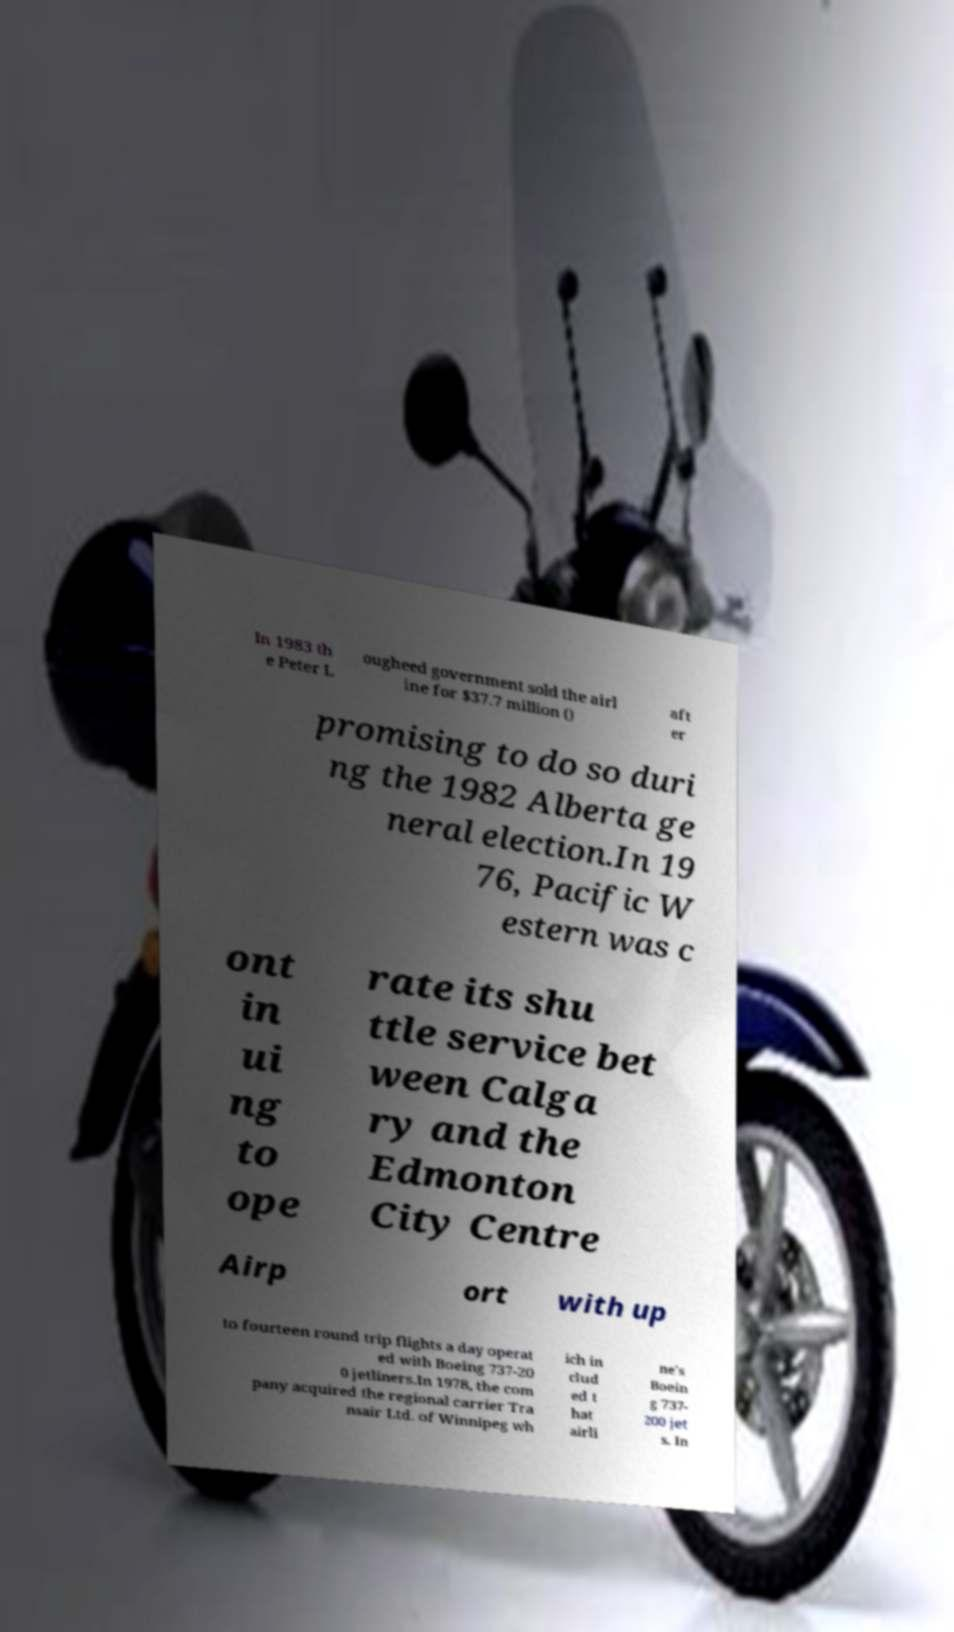What messages or text are displayed in this image? I need them in a readable, typed format. In 1983 th e Peter L ougheed government sold the airl ine for $37.7 million () aft er promising to do so duri ng the 1982 Alberta ge neral election.In 19 76, Pacific W estern was c ont in ui ng to ope rate its shu ttle service bet ween Calga ry and the Edmonton City Centre Airp ort with up to fourteen round trip flights a day operat ed with Boeing 737-20 0 jetliners.In 1978, the com pany acquired the regional carrier Tra nsair Ltd. of Winnipeg wh ich in clud ed t hat airli ne's Boein g 737- 200 jet s. In 